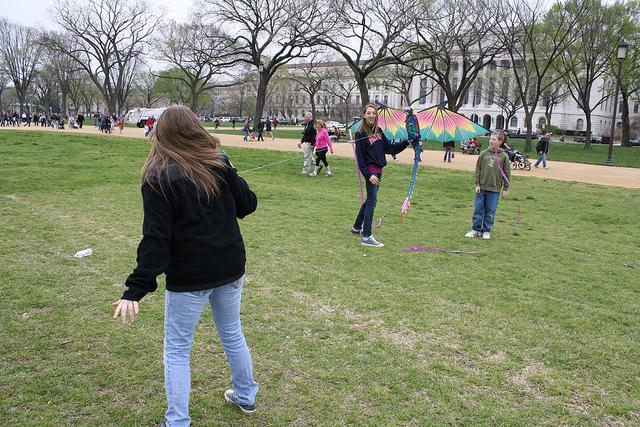What would you likely put in the thing on the ground that looks like garbage?

Choices:
A) hamburger
B) dollar bills
C) toys
D) water water 